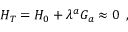Convert formula to latex. <formula><loc_0><loc_0><loc_500><loc_500>H _ { T } = H _ { 0 } + \lambda ^ { a } G _ { a } \approx 0 \, ,</formula> 